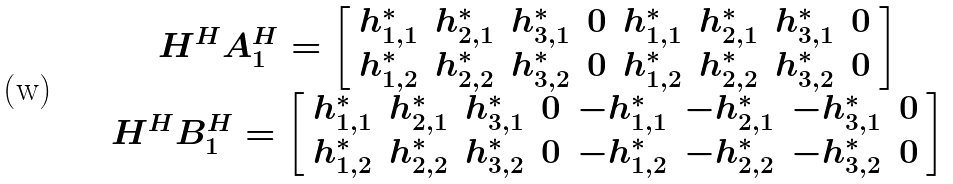Convert formula to latex. <formula><loc_0><loc_0><loc_500><loc_500>\begin{array} { c } H ^ { H } A _ { 1 } ^ { H } = \left [ \begin{array} { c c c c c c c c } h _ { 1 , 1 } ^ { * } & h _ { 2 , 1 } ^ { * } & h _ { 3 , 1 } ^ { * } & 0 & h _ { 1 , 1 } ^ { * } & h _ { 2 , 1 } ^ { * } & h _ { 3 , 1 } ^ { * } & 0 \\ h _ { 1 , 2 } ^ { * } & h _ { 2 , 2 } ^ { * } & h _ { 3 , 2 } ^ { * } & 0 & h _ { 1 , 2 } ^ { * } & h _ { 2 , 2 } ^ { * } & h _ { 3 , 2 } ^ { * } & 0 \\ \end{array} \right ] \\ H ^ { H } B _ { 1 } ^ { H } = \left [ \begin{array} { c c c c c c c c } h _ { 1 , 1 } ^ { * } & h _ { 2 , 1 } ^ { * } & h _ { 3 , 1 } ^ { * } & 0 & - h _ { 1 , 1 } ^ { * } & - h _ { 2 , 1 } ^ { * } & - h _ { 3 , 1 } ^ { * } & 0 \\ h _ { 1 , 2 } ^ { * } & h _ { 2 , 2 } ^ { * } & h _ { 3 , 2 } ^ { * } & 0 & - h _ { 1 , 2 } ^ { * } & - h _ { 2 , 2 } ^ { * } & - h _ { 3 , 2 } ^ { * } & 0 \\ \end{array} \right ] \end{array}</formula> 